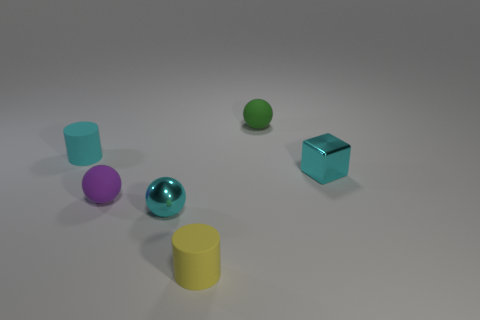How many objects are tiny yellow cylinders in front of the shiny sphere or tiny matte cylinders that are in front of the tiny cyan metal ball?
Provide a succinct answer. 1. Does the tiny cyan sphere have the same material as the sphere to the right of the yellow cylinder?
Ensure brevity in your answer.  No. What number of other things are there of the same shape as the tiny yellow thing?
Your response must be concise. 1. What material is the thing that is right of the tiny sphere behind the small matte cylinder that is to the left of the small yellow cylinder made of?
Keep it short and to the point. Metal. Are there the same number of purple matte spheres in front of the purple rubber object and small cylinders?
Keep it short and to the point. No. Does the tiny cyan thing in front of the purple thing have the same material as the small block in front of the tiny green rubber sphere?
Offer a very short reply. Yes. Is there any other thing that is the same material as the yellow cylinder?
Your response must be concise. Yes. Do the thing right of the small green matte sphere and the cyan thing in front of the tiny purple ball have the same shape?
Ensure brevity in your answer.  No. Is the number of purple rubber spheres in front of the purple rubber object less than the number of gray matte cubes?
Offer a very short reply. No. How many other balls have the same color as the small metal ball?
Your answer should be very brief. 0. 